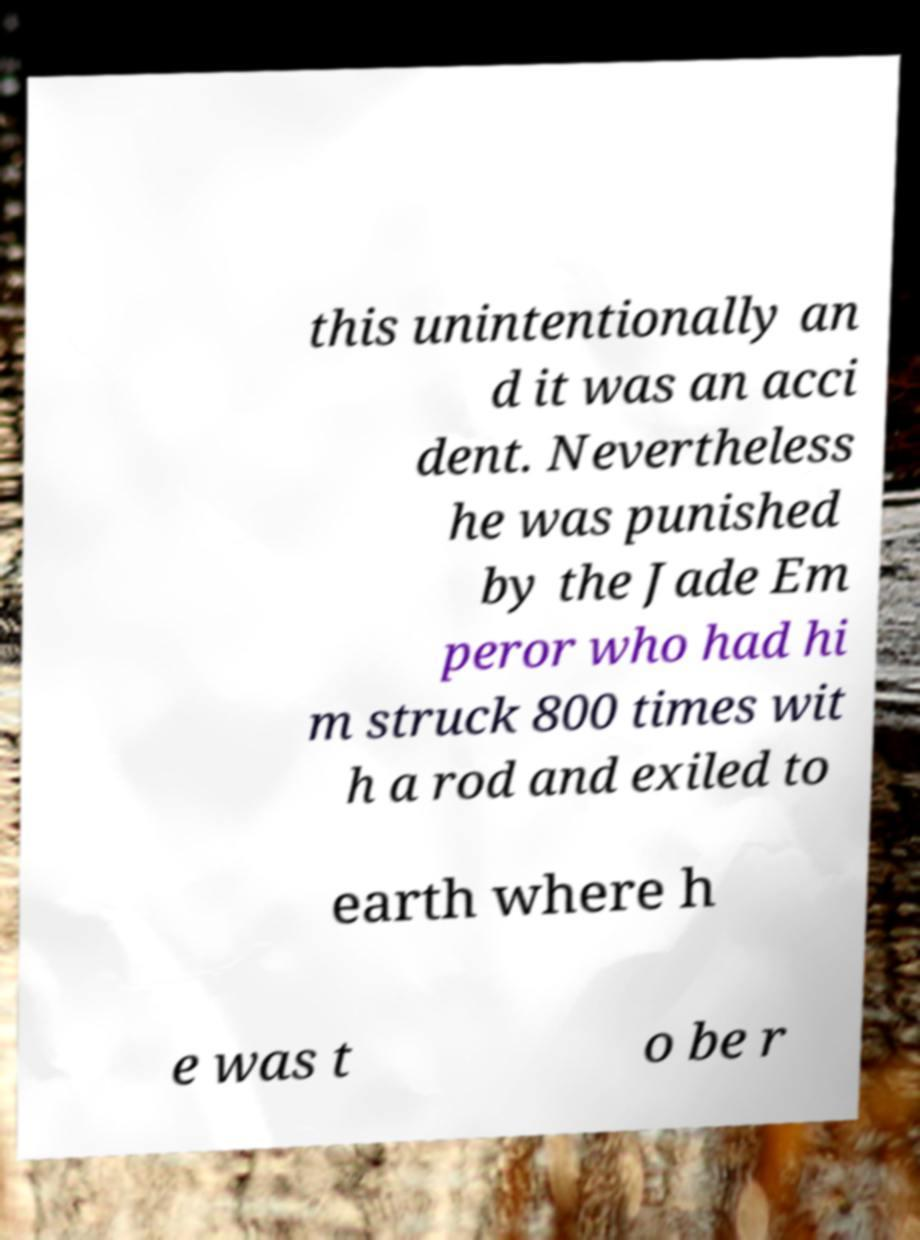Can you accurately transcribe the text from the provided image for me? this unintentionally an d it was an acci dent. Nevertheless he was punished by the Jade Em peror who had hi m struck 800 times wit h a rod and exiled to earth where h e was t o be r 